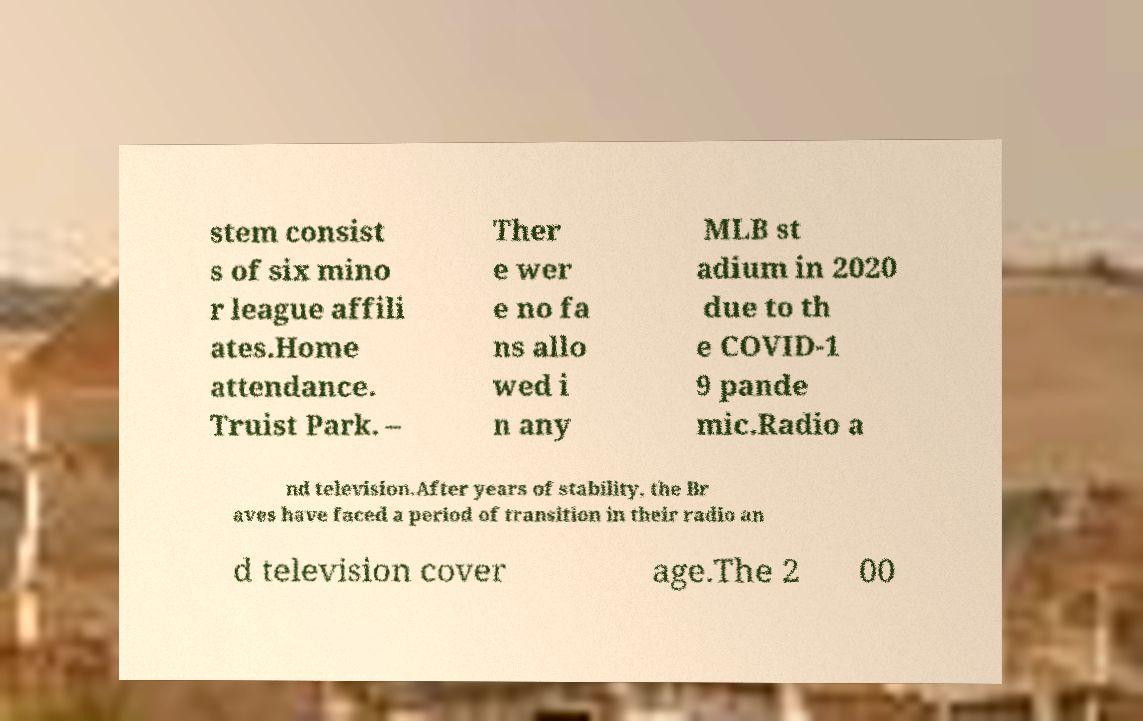For documentation purposes, I need the text within this image transcribed. Could you provide that? stem consist s of six mino r league affili ates.Home attendance. Truist Park. – Ther e wer e no fa ns allo wed i n any MLB st adium in 2020 due to th e COVID-1 9 pande mic.Radio a nd television.After years of stability, the Br aves have faced a period of transition in their radio an d television cover age.The 2 00 